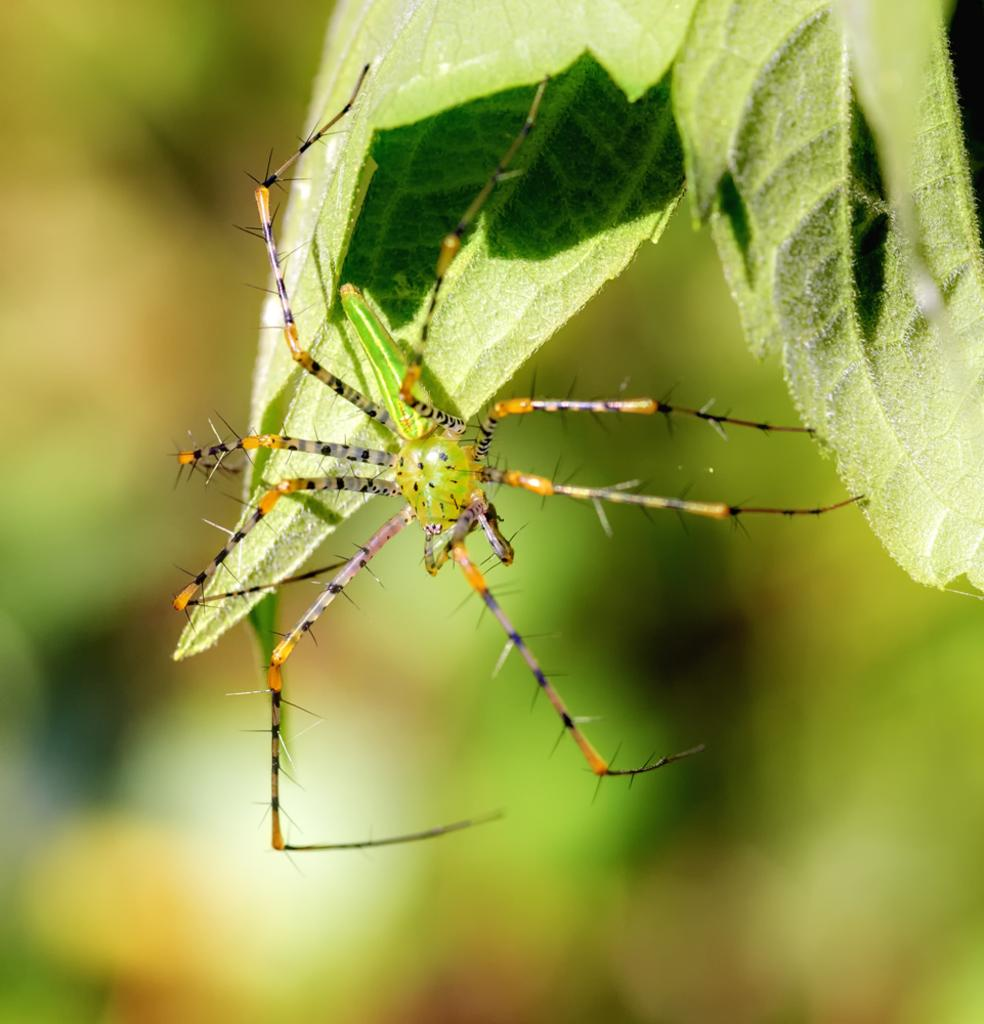What is present in the image? There is an insect in the image. Where is the insect located? The insect is on leaves. Can you describe the background of the image? The background of the image is blurred. What type of fuel is the insect using to fly in the image? The insect does not appear to be flying in the image, and insects do not use fuel to fly. They have wings and use their muscles to generate lift and propel themselves through the air. 